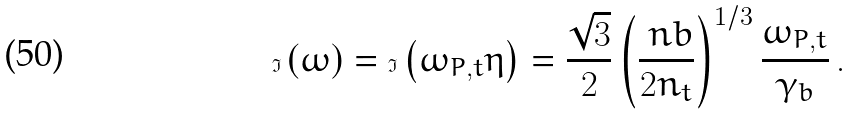<formula> <loc_0><loc_0><loc_500><loc_500>\Im \left ( \omega \right ) = \Im \left ( \omega _ { P , t } \eta \right ) = \frac { \sqrt { 3 } } { 2 } \left ( \frac { \ n b } { 2 n _ { t } } \right ) ^ { 1 / 3 } \frac { \omega _ { P , t } } { \gamma _ { b } } \, .</formula> 